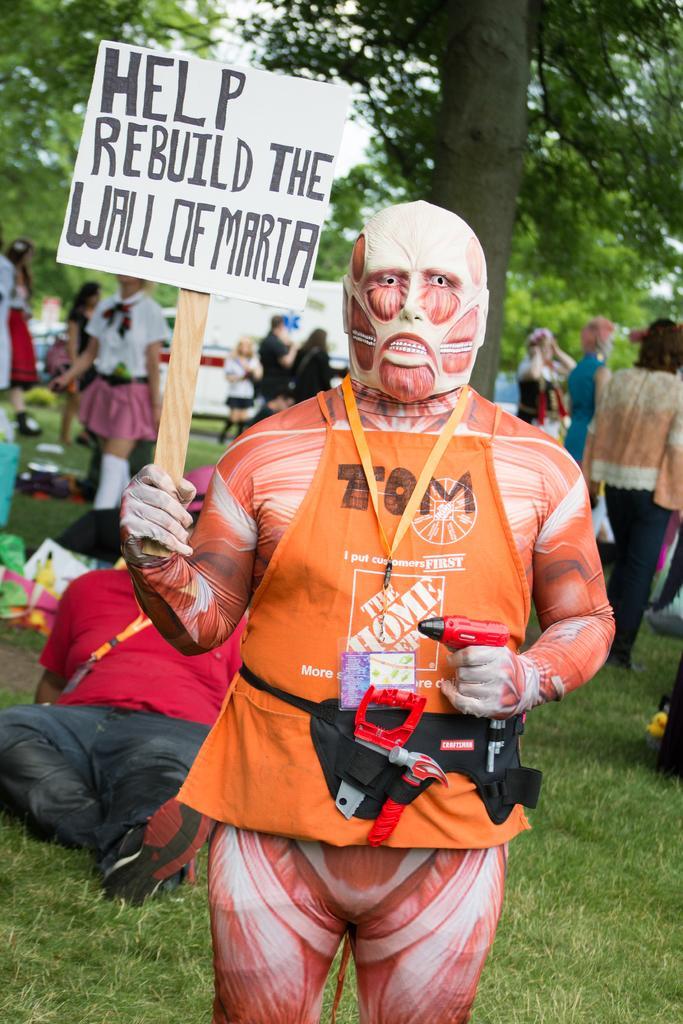Please provide a concise description of this image. In this image we can see a person wearing a costume and holding a board with some text. We can see some people in the background and there are some objects on the ground and we can see some trees. 